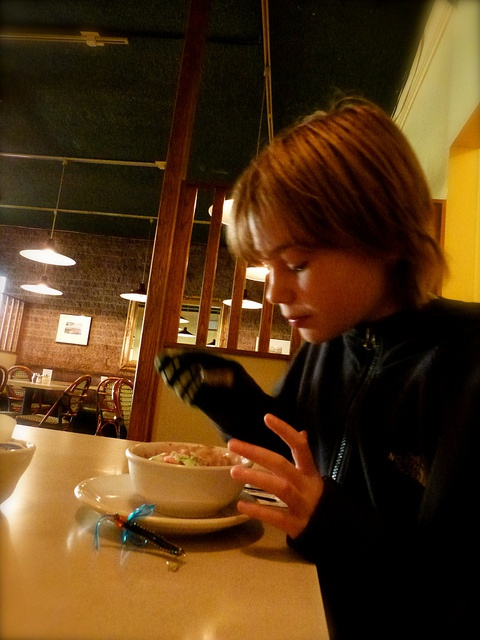Describe the objects in this image and their specific colors. I can see people in black, maroon, and brown tones, dining table in black, orange, tan, and maroon tones, bowl in black, red, tan, and maroon tones, chair in black, maroon, and olive tones, and bowl in black, olive, tan, and gray tones in this image. 